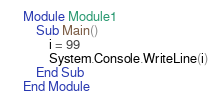<code> <loc_0><loc_0><loc_500><loc_500><_VisualBasic_>    Module Module1
        Sub Main()
            i = 99
            System.Console.WriteLine(i)
        End Sub
    End Module</code> 